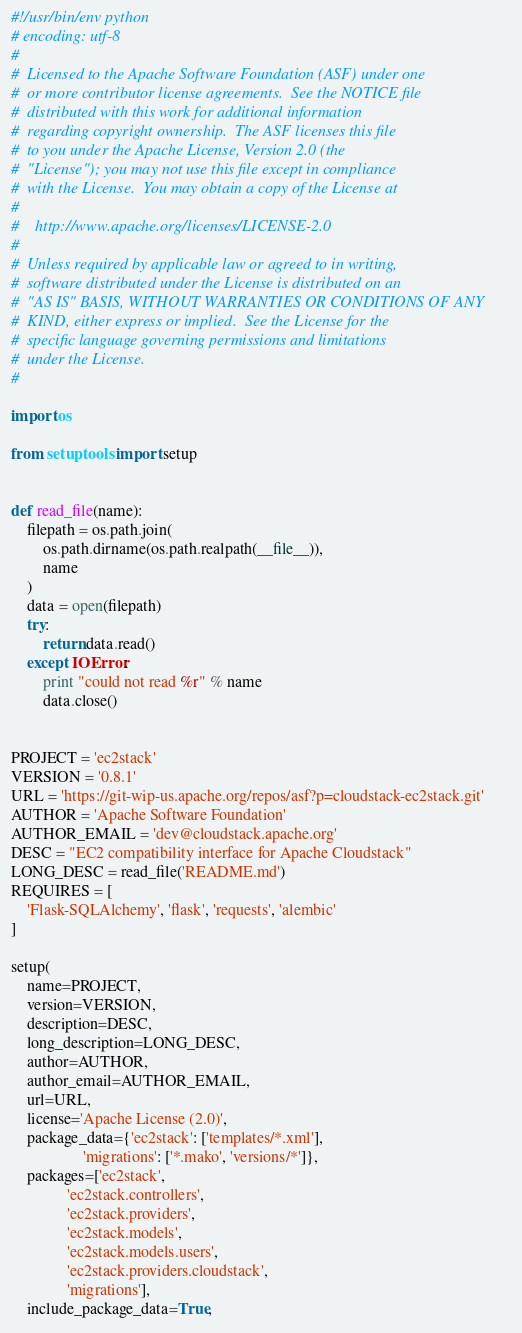<code> <loc_0><loc_0><loc_500><loc_500><_Python_>#!/usr/bin/env python
# encoding: utf-8
#
#  Licensed to the Apache Software Foundation (ASF) under one
#  or more contributor license agreements.  See the NOTICE file
#  distributed with this work for additional information
#  regarding copyright ownership.  The ASF licenses this file
#  to you under the Apache License, Version 2.0 (the
#  "License"); you may not use this file except in compliance
#  with the License.  You may obtain a copy of the License at
#
#    http://www.apache.org/licenses/LICENSE-2.0
#
#  Unless required by applicable law or agreed to in writing,
#  software distributed under the License is distributed on an
#  "AS IS" BASIS, WITHOUT WARRANTIES OR CONDITIONS OF ANY
#  KIND, either express or implied.  See the License for the
#  specific language governing permissions and limitations
#  under the License.
#

import os

from setuptools import setup


def read_file(name):
    filepath = os.path.join(
        os.path.dirname(os.path.realpath(__file__)),
        name
    )
    data = open(filepath)
    try:
        return data.read()
    except IOError:
        print "could not read %r" % name
        data.close()


PROJECT = 'ec2stack'
VERSION = '0.8.1'
URL = 'https://git-wip-us.apache.org/repos/asf?p=cloudstack-ec2stack.git'
AUTHOR = 'Apache Software Foundation'
AUTHOR_EMAIL = 'dev@cloudstack.apache.org'
DESC = "EC2 compatibility interface for Apache Cloudstack"
LONG_DESC = read_file('README.md')
REQUIRES = [
    'Flask-SQLAlchemy', 'flask', 'requests', 'alembic'
]

setup(
    name=PROJECT,
    version=VERSION,
    description=DESC,
    long_description=LONG_DESC,
    author=AUTHOR,
    author_email=AUTHOR_EMAIL,
    url=URL,
    license='Apache License (2.0)',
    package_data={'ec2stack': ['templates/*.xml'],
                  'migrations': ['*.mako', 'versions/*']},
    packages=['ec2stack',
              'ec2stack.controllers',
              'ec2stack.providers',
              'ec2stack.models',
              'ec2stack.models.users',
              'ec2stack.providers.cloudstack',
              'migrations'],
    include_package_data=True,</code> 